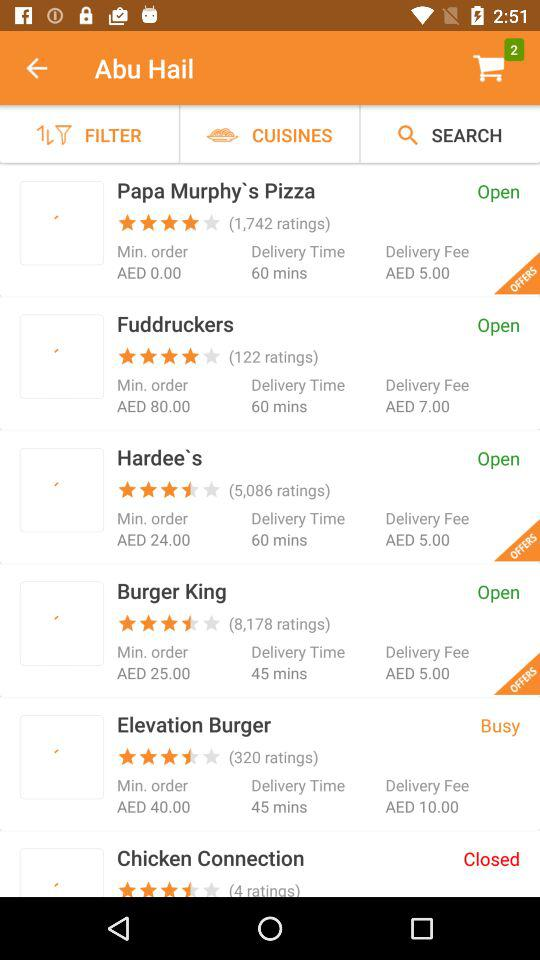What is the delivery fee for "Elevation Burger"? The delivery fee is AED 10. 